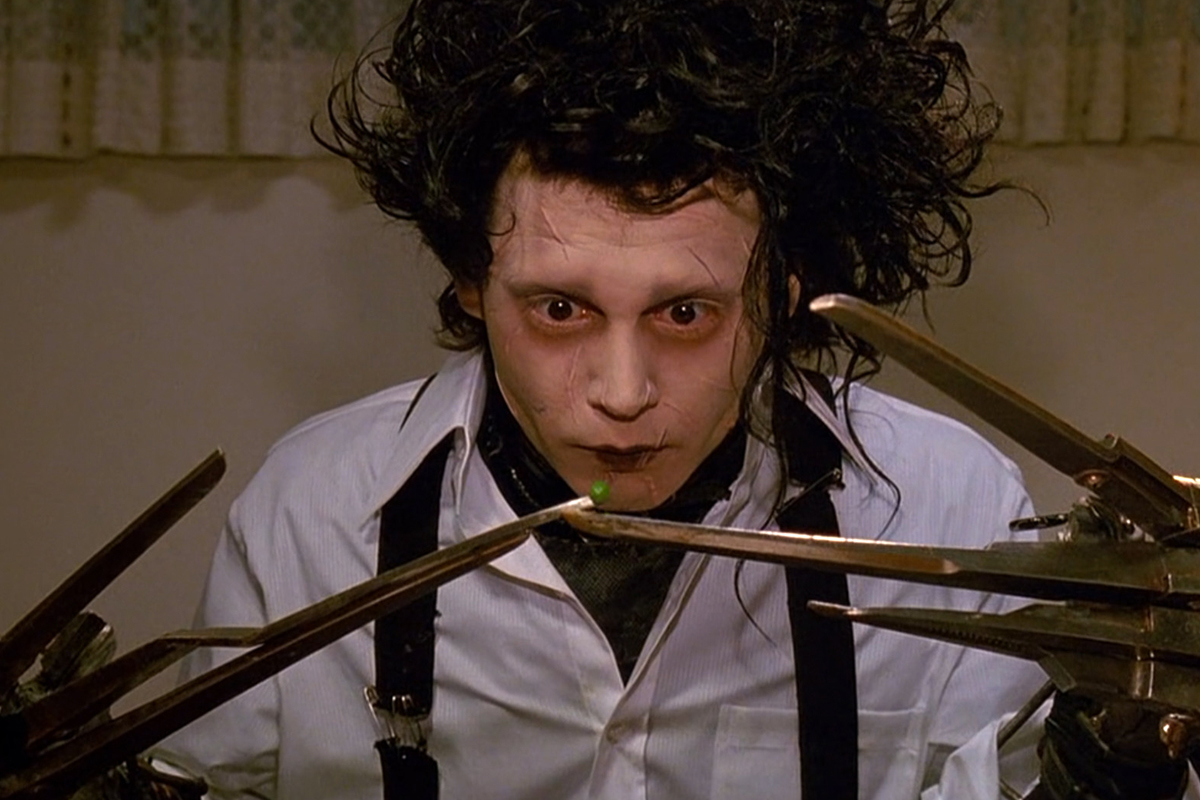What are the key elements in this picture? This image shows a striking frame from the movie 'Edward Scissorhands,' featuring the character Edward portrayed by Johnny Depp. Key visual elements include Edward's pale, sharply contoured face, complemented by dark, deep-set eyes and unruly black hair that add to his otherworldly appearance. His costume consists of a stark white shirt and black tie which contrasts dramatically with his skin tone and the dark setting of the scene. Central to his character are the scissor hands, which are not only literal tools but also symbolize his unique creative abilities and the isolation they bring. His expression and posture convey a profound melancholy and vulnerability, encapsulating the central themes of the film such as isolation and the struggle for acceptance. 